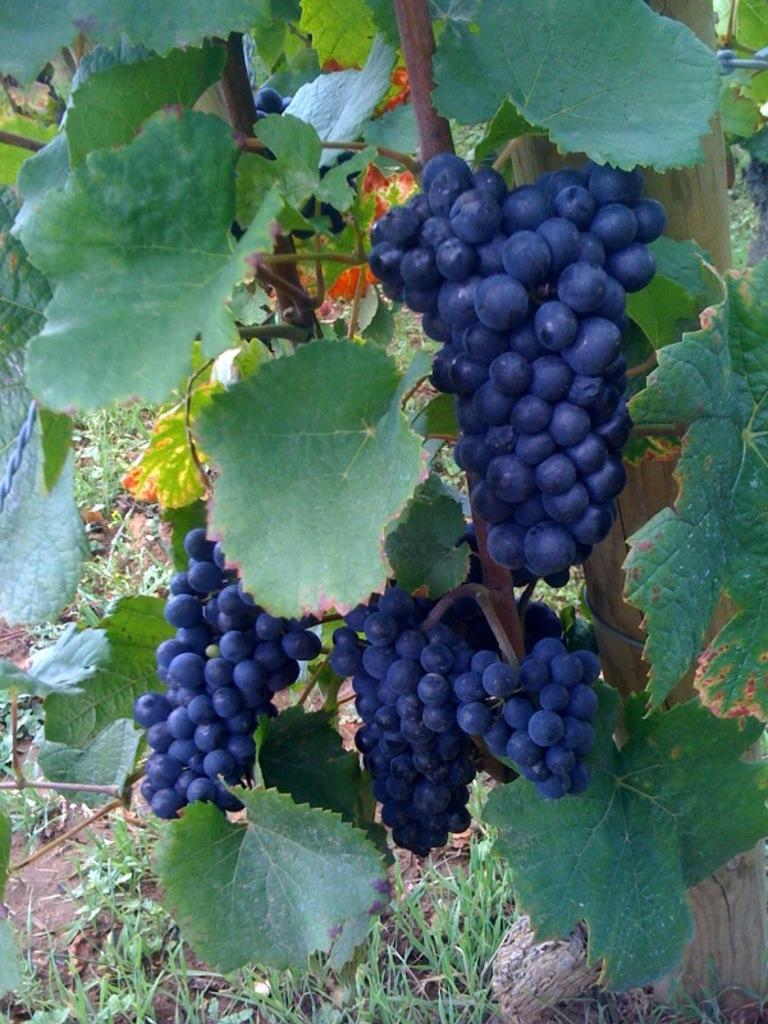What type of plants are in the image? There are grape plants in the image. What can be seen beneath the plants? The ground is visible in the image. What type of vegetation covers the ground? There is grass on the ground. What type of glove can be seen hanging from the grape plants in the image? There is no glove present in the image; it only features grape plants, the ground, and grass. 